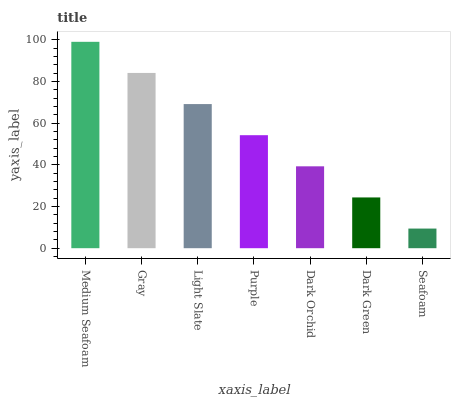Is Gray the minimum?
Answer yes or no. No. Is Gray the maximum?
Answer yes or no. No. Is Medium Seafoam greater than Gray?
Answer yes or no. Yes. Is Gray less than Medium Seafoam?
Answer yes or no. Yes. Is Gray greater than Medium Seafoam?
Answer yes or no. No. Is Medium Seafoam less than Gray?
Answer yes or no. No. Is Purple the high median?
Answer yes or no. Yes. Is Purple the low median?
Answer yes or no. Yes. Is Dark Orchid the high median?
Answer yes or no. No. Is Gray the low median?
Answer yes or no. No. 